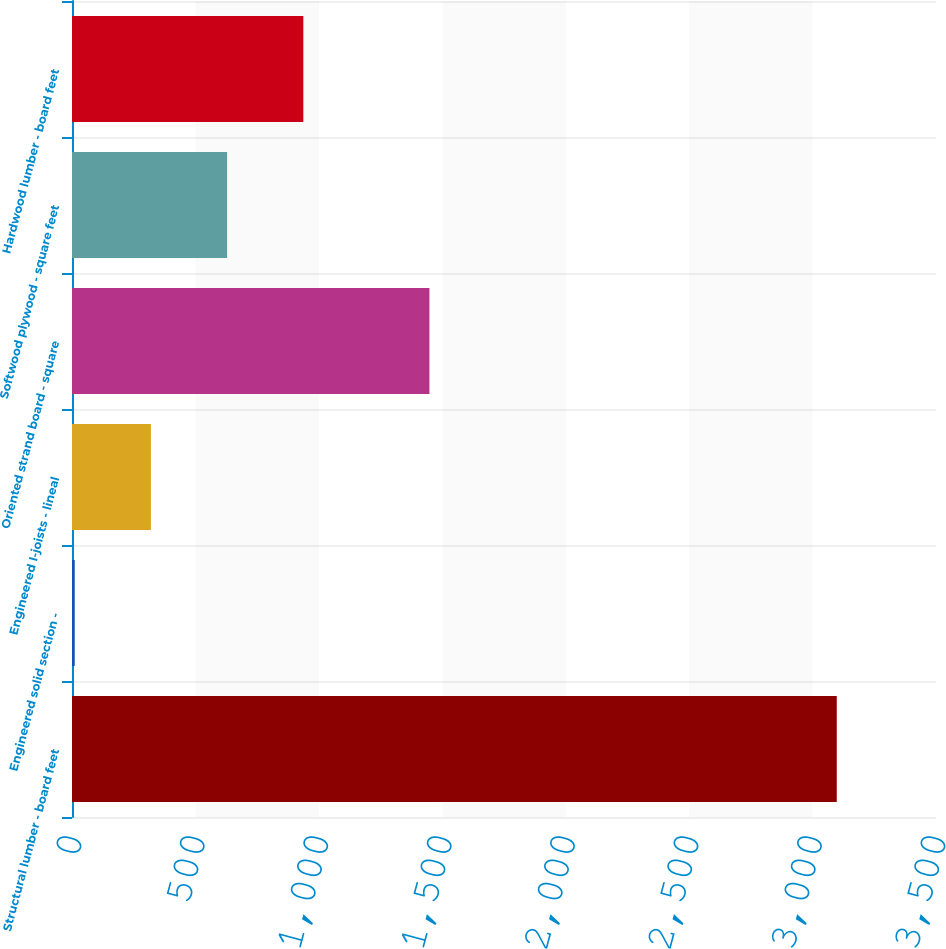<chart> <loc_0><loc_0><loc_500><loc_500><bar_chart><fcel>Structural lumber - board feet<fcel>Engineered solid section -<fcel>Engineered I-joists - lineal<fcel>Oriented strand board - square<fcel>Softwood plywood - square feet<fcel>Hardwood lumber - board feet<nl><fcel>3098<fcel>11<fcel>319.7<fcel>1448<fcel>628.4<fcel>937.1<nl></chart> 